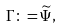<formula> <loc_0><loc_0><loc_500><loc_500>\Gamma \colon = \widetilde { \Psi } ,</formula> 